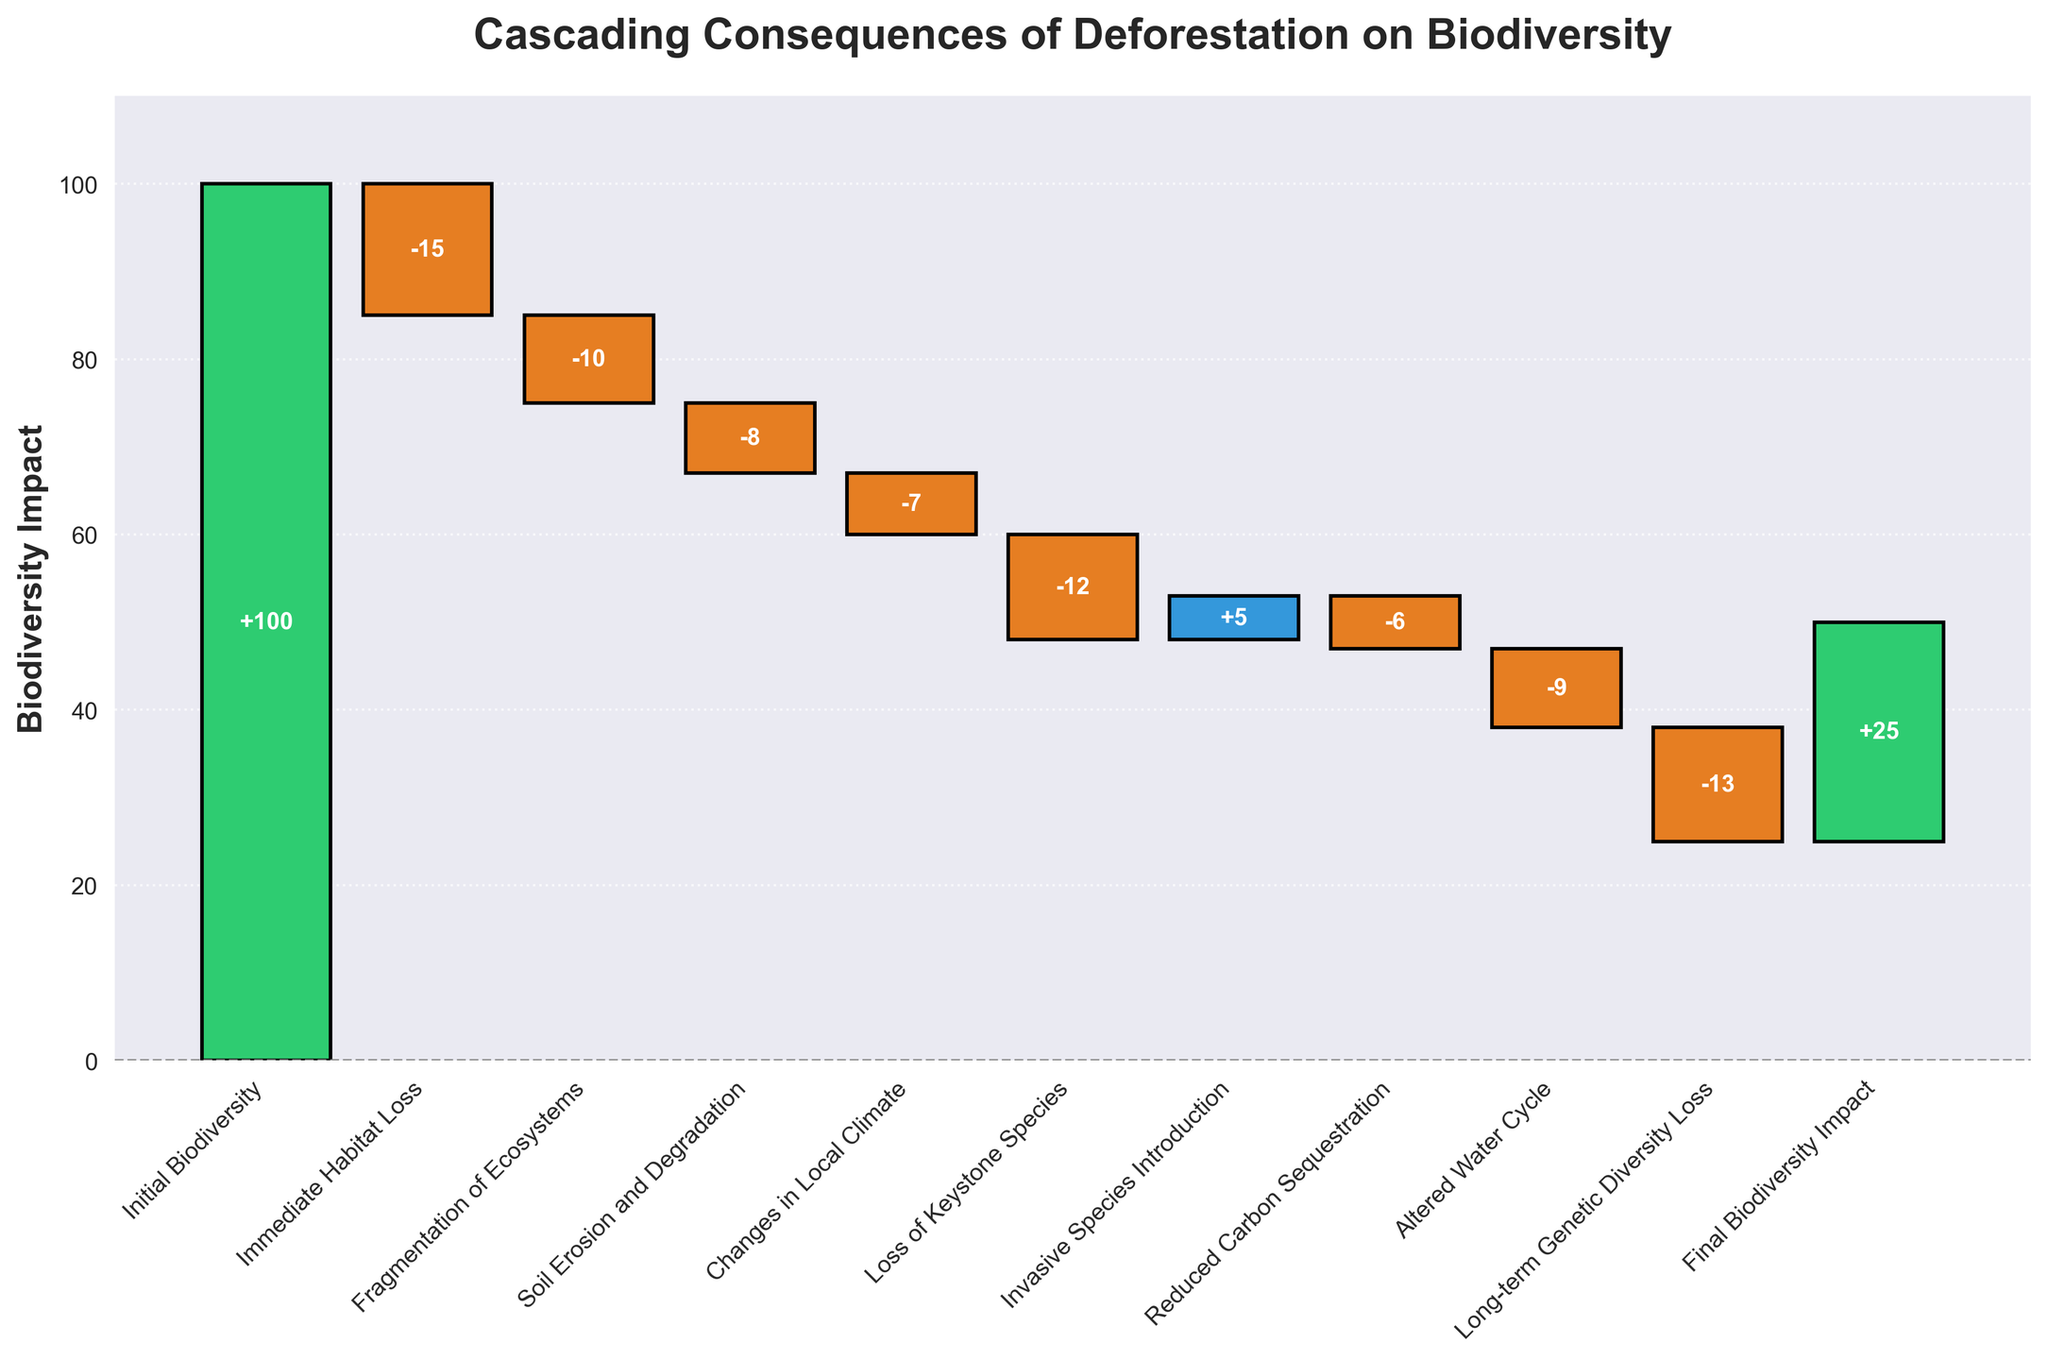What is the title of the chart? The title is shown at the top of the chart, which states the subject of the figure.
Answer: Cascading Consequences of Deforestation on Biodiversity How many categories are listed in the chart? By counting the labels on the x-axis, we see there are 11 categories listed in the chart.
Answer: 11 What are the two largest negative impacts on biodiversity shown in the chart? By observing the lengths of the negative bars, the longest ones represent the largest negative impacts. The "Loss of Keystone Species" has a value of -12, and "Long-term Genetic Diversity Loss" has a value of -13.
Answer: Loss of Keystone Species and Long-term Genetic Diversity Loss What is the cumulative impact on biodiversity after "Soil Erosion and Degradation"? Calculate the cumulative impact step by step up to "Soil Erosion and Degradation": 100 (initial) - 15 - 10 - 8 = 67.
Answer: 67 Which category shows a positive contribution to biodiversity? By identifying the direction and color of the bars, the only positive contribution is "Invasive Species Introduction" with a +5 value.
Answer: Invasive Species Introduction What is the net change in biodiversity from "Changes in Local Climate" to "Reduced Carbon Sequestration"? Add the values for each effect in the given range. Changes in Local Climate (-7) + Loss of Keystone Species (-12) + Invasive Species Introduction (+5) + Reduced Carbon Sequestration (-6): -7 -12 +5 -6 = -20.
Answer: -20 What is the final biodiversity impact value shown in the chart? The final value is displayed at the end of the cumulative visualization, denoted as "Final Biodiversity Impact" with a value of 25.
Answer: 25 How does the impact of "Fragmentation of Ecosystems" compare to "Altered Water Cycle"? Compare the values of "Fragmentation of Ecosystems" (-10) and "Altered Water Cycle" (-9): -10 is less than -9 in terms of impact intensity.
Answer: Fragmentation of Ecosystems has a greater negative impact than Altered Water Cycle What overall trend is depicted by the chart? Analyzing the sequence of the bar changes from the initial biodiversity value to the final, there is a general downward trend with significant negative impacts, and only slight recovery.
Answer: Downward trend with significant negative impacts Which impact has a greater cumulative effect: "Soil Erosion and Degradation" through "Altered Water Cycle" or "Loss of Keystone Species" through "Final Biodiversity Impact"? Calculate the cumulative effects for both ranges:
- Soil Erosion and Degradation through Altered Water Cycle: -8 - 7 - 12 + 5 - 6 - 9 = -37
- Loss of Keystone Species through Final Biodiversity Impact: -12 + 5 - 6 - 9 - 13 = -35
Thus, the first range has a greater cumulative negative effect.
Answer: Soil Erosion and Degradation through Altered Water Cycle 